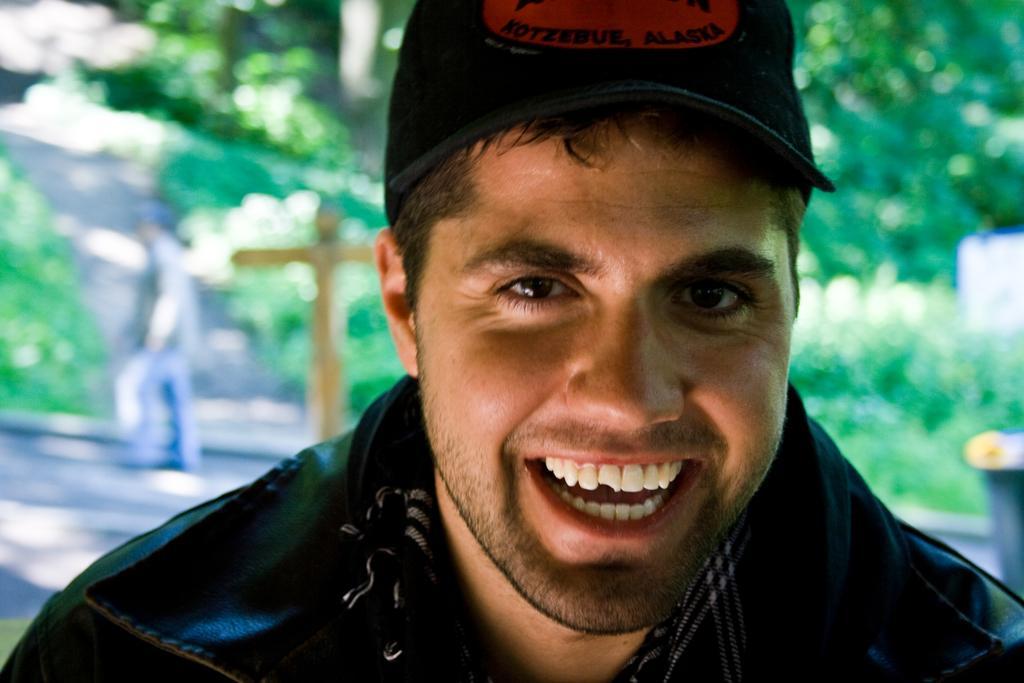Could you give a brief overview of what you see in this image? In this picture there is a man with black jacket. At the back there are trees and there is a person walking and there are objects. 